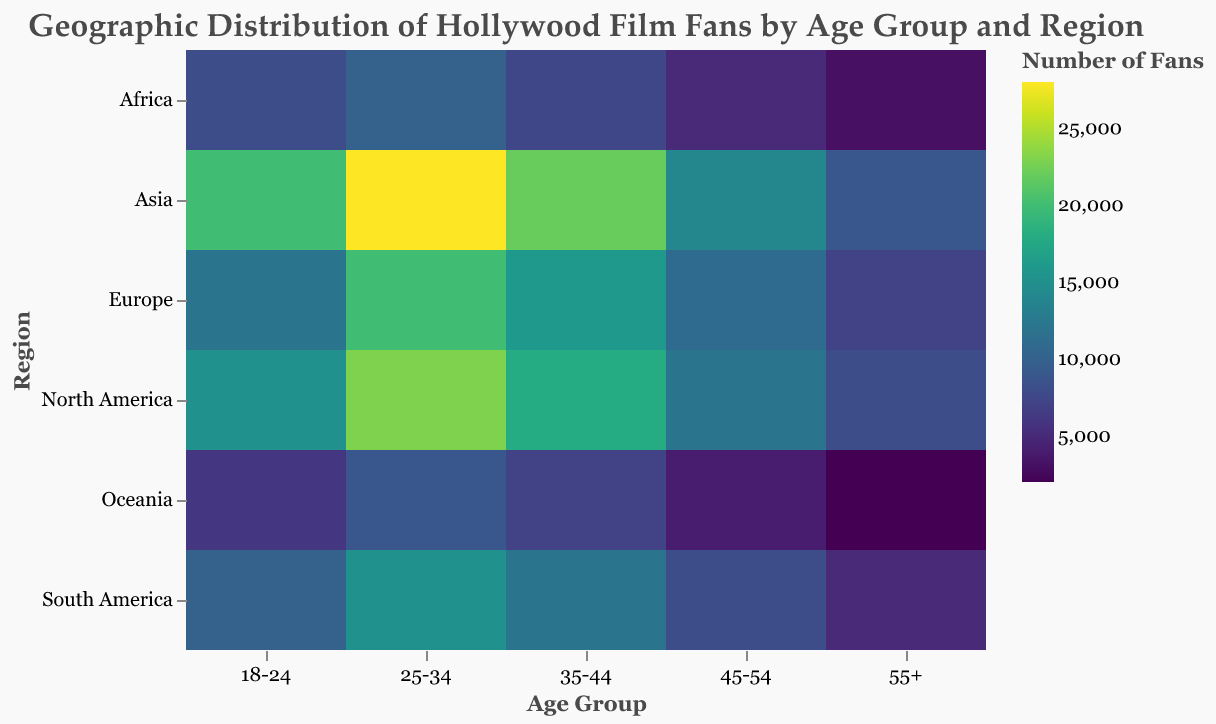What's the title of the heatmap? On the top of the figure, it reads, "Geographic Distribution of Hollywood Film Fans by Age Group and Region".
Answer: Geographic Distribution of Hollywood Film Fans by Age Group and Region Which age group in North America has the highest number of fans? In the North America row, the cell for the 25-34 age group has the darkest color and a tooltip value of 23000.
Answer: 25-34 How many fans are there in the 45-54 age group in Europe? Hovering over the cell for the 45-54 age group in Europe shows a tooltip with a value of 11000.
Answer: 11000 Compare the number of fans aged 18-24 in Asia and North America. Which region has more fans? The Asian region cell for the 18-24 age group shows 20000 fans, while the North American region cell shows 15000 fans.
Answer: Asia In which region and age group do we see the lowest number of fans? The cell with the lightest color represents the 55+ age group in Oceania, with a value of 2000 fans.
Answer: Oceania, 55+ What is the total number of fans in the 35-44 age group across all regions? Summing the values: North America (18000) + Europe (16000) + Asia (22000) + South America (12000) + Africa (7500) + Oceania (7000) = 82500.
Answer: 82500 Which regions have fewer fans for the 55+ age group compared to Africa in the same age group? Africa has 3000 fans for the 55+ age group. Oceania has fewer fans with only 2000.
Answer: Oceania Which age group has the most fans on average across all regions? Summing the fans for each age group and dividing by the number of regions (6): 18-24: (15000+12000+20000+10000+8000+6000)/6 = 11833.33, 25-34: (23000+20000+28000+15000+10000+9000)/6 = 17500, 35-44: (18000+16000+22000+12000+7500+7000)/6 = 13750, 45-54: (12000+11000+14000+8000+5000+4000)/6 = 8683.33, 55+: (8000+7000+9000+5000+3000+2000)/6 = 5666.67. So, 25-34 is the highest on average.
Answer: 25-34 Is the number of fans aged 55+ in North America higher or lower than those aged 45-54 in South America? North America's 55+ age group has 8000 fans, while South America's 45-54 age group has 8000 fans. They are equal.
Answer: Equal 